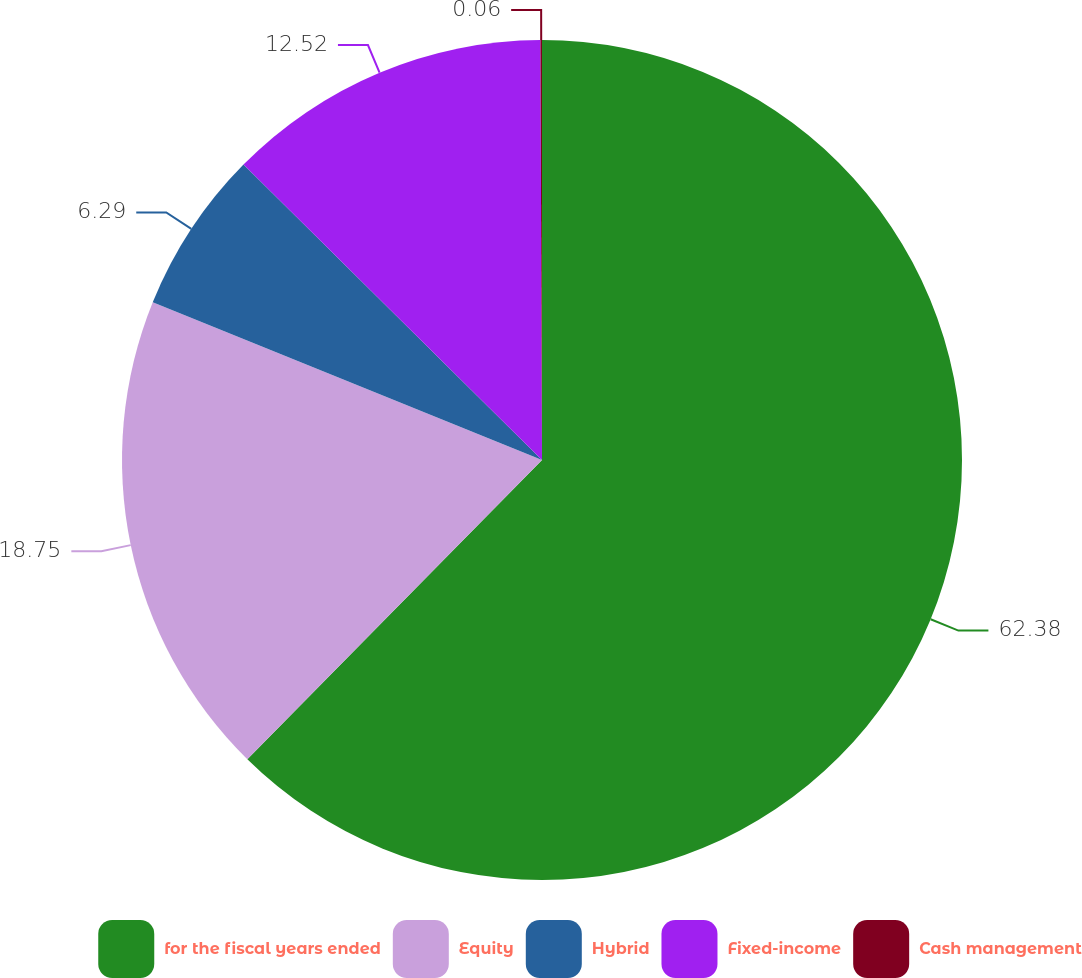<chart> <loc_0><loc_0><loc_500><loc_500><pie_chart><fcel>for the fiscal years ended<fcel>Equity<fcel>Hybrid<fcel>Fixed-income<fcel>Cash management<nl><fcel>62.37%<fcel>18.75%<fcel>6.29%<fcel>12.52%<fcel>0.06%<nl></chart> 